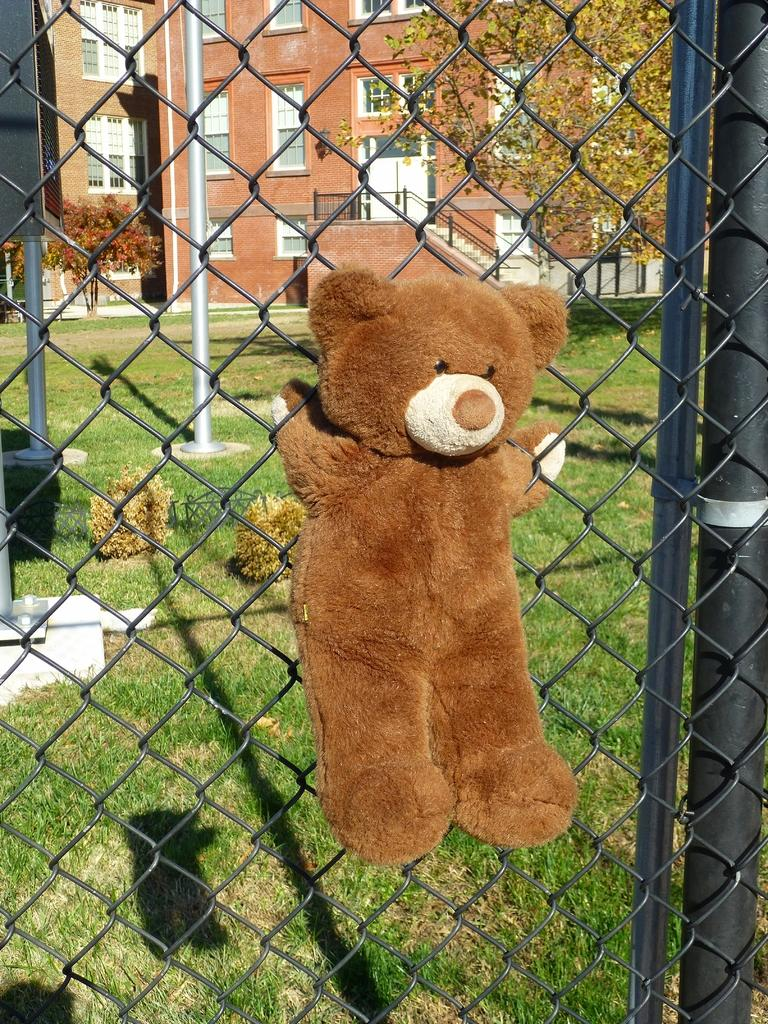What is the main subject of the image? The main subject of the image is a doll. How is the doll positioned in the image? The doll is attached to a net. What can be seen in the background of the image? There are trees and buildings in the background of the image. What type of ground is visible at the bottom of the image? Grass is present at the bottom of the image. What type of hook is attached to the doll's tail in the image? There is no hook or tail present on the doll in the image. 